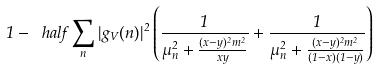Convert formula to latex. <formula><loc_0><loc_0><loc_500><loc_500>1 - \ h a l f \sum _ { n } | g _ { V } ( n ) | ^ { 2 } \left ( \frac { 1 } { \mu _ { n } ^ { 2 } + \frac { ( x - y ) ^ { 2 } m ^ { 2 } } { x y } } + \frac { 1 } { \mu _ { n } ^ { 2 } + \frac { ( x - y ) ^ { 2 } m ^ { 2 } } { ( 1 - x ) ( 1 - y ) } } \right )</formula> 